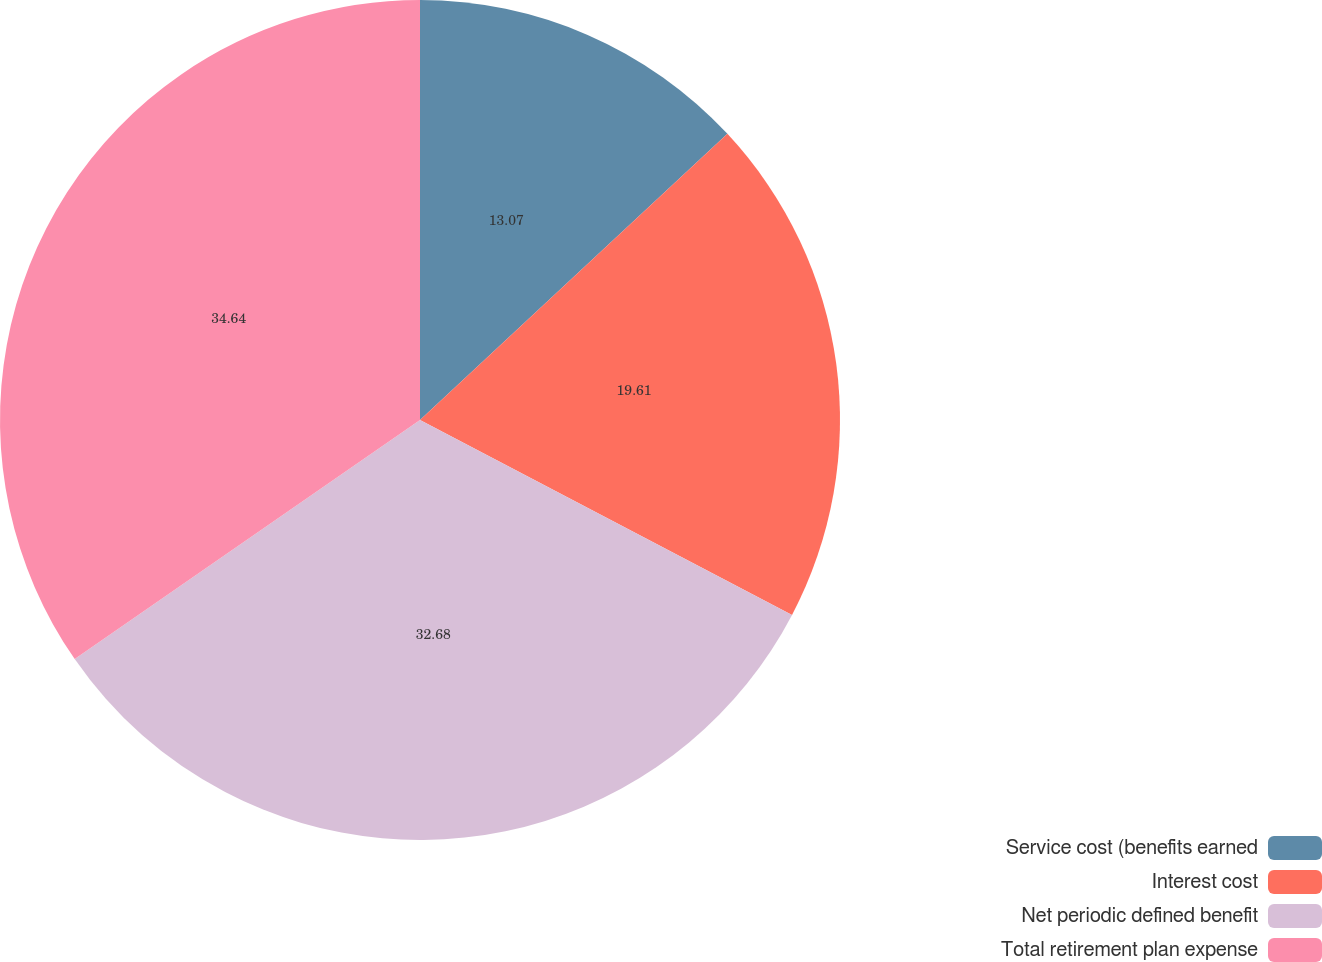<chart> <loc_0><loc_0><loc_500><loc_500><pie_chart><fcel>Service cost (benefits earned<fcel>Interest cost<fcel>Net periodic defined benefit<fcel>Total retirement plan expense<nl><fcel>13.07%<fcel>19.61%<fcel>32.68%<fcel>34.64%<nl></chart> 